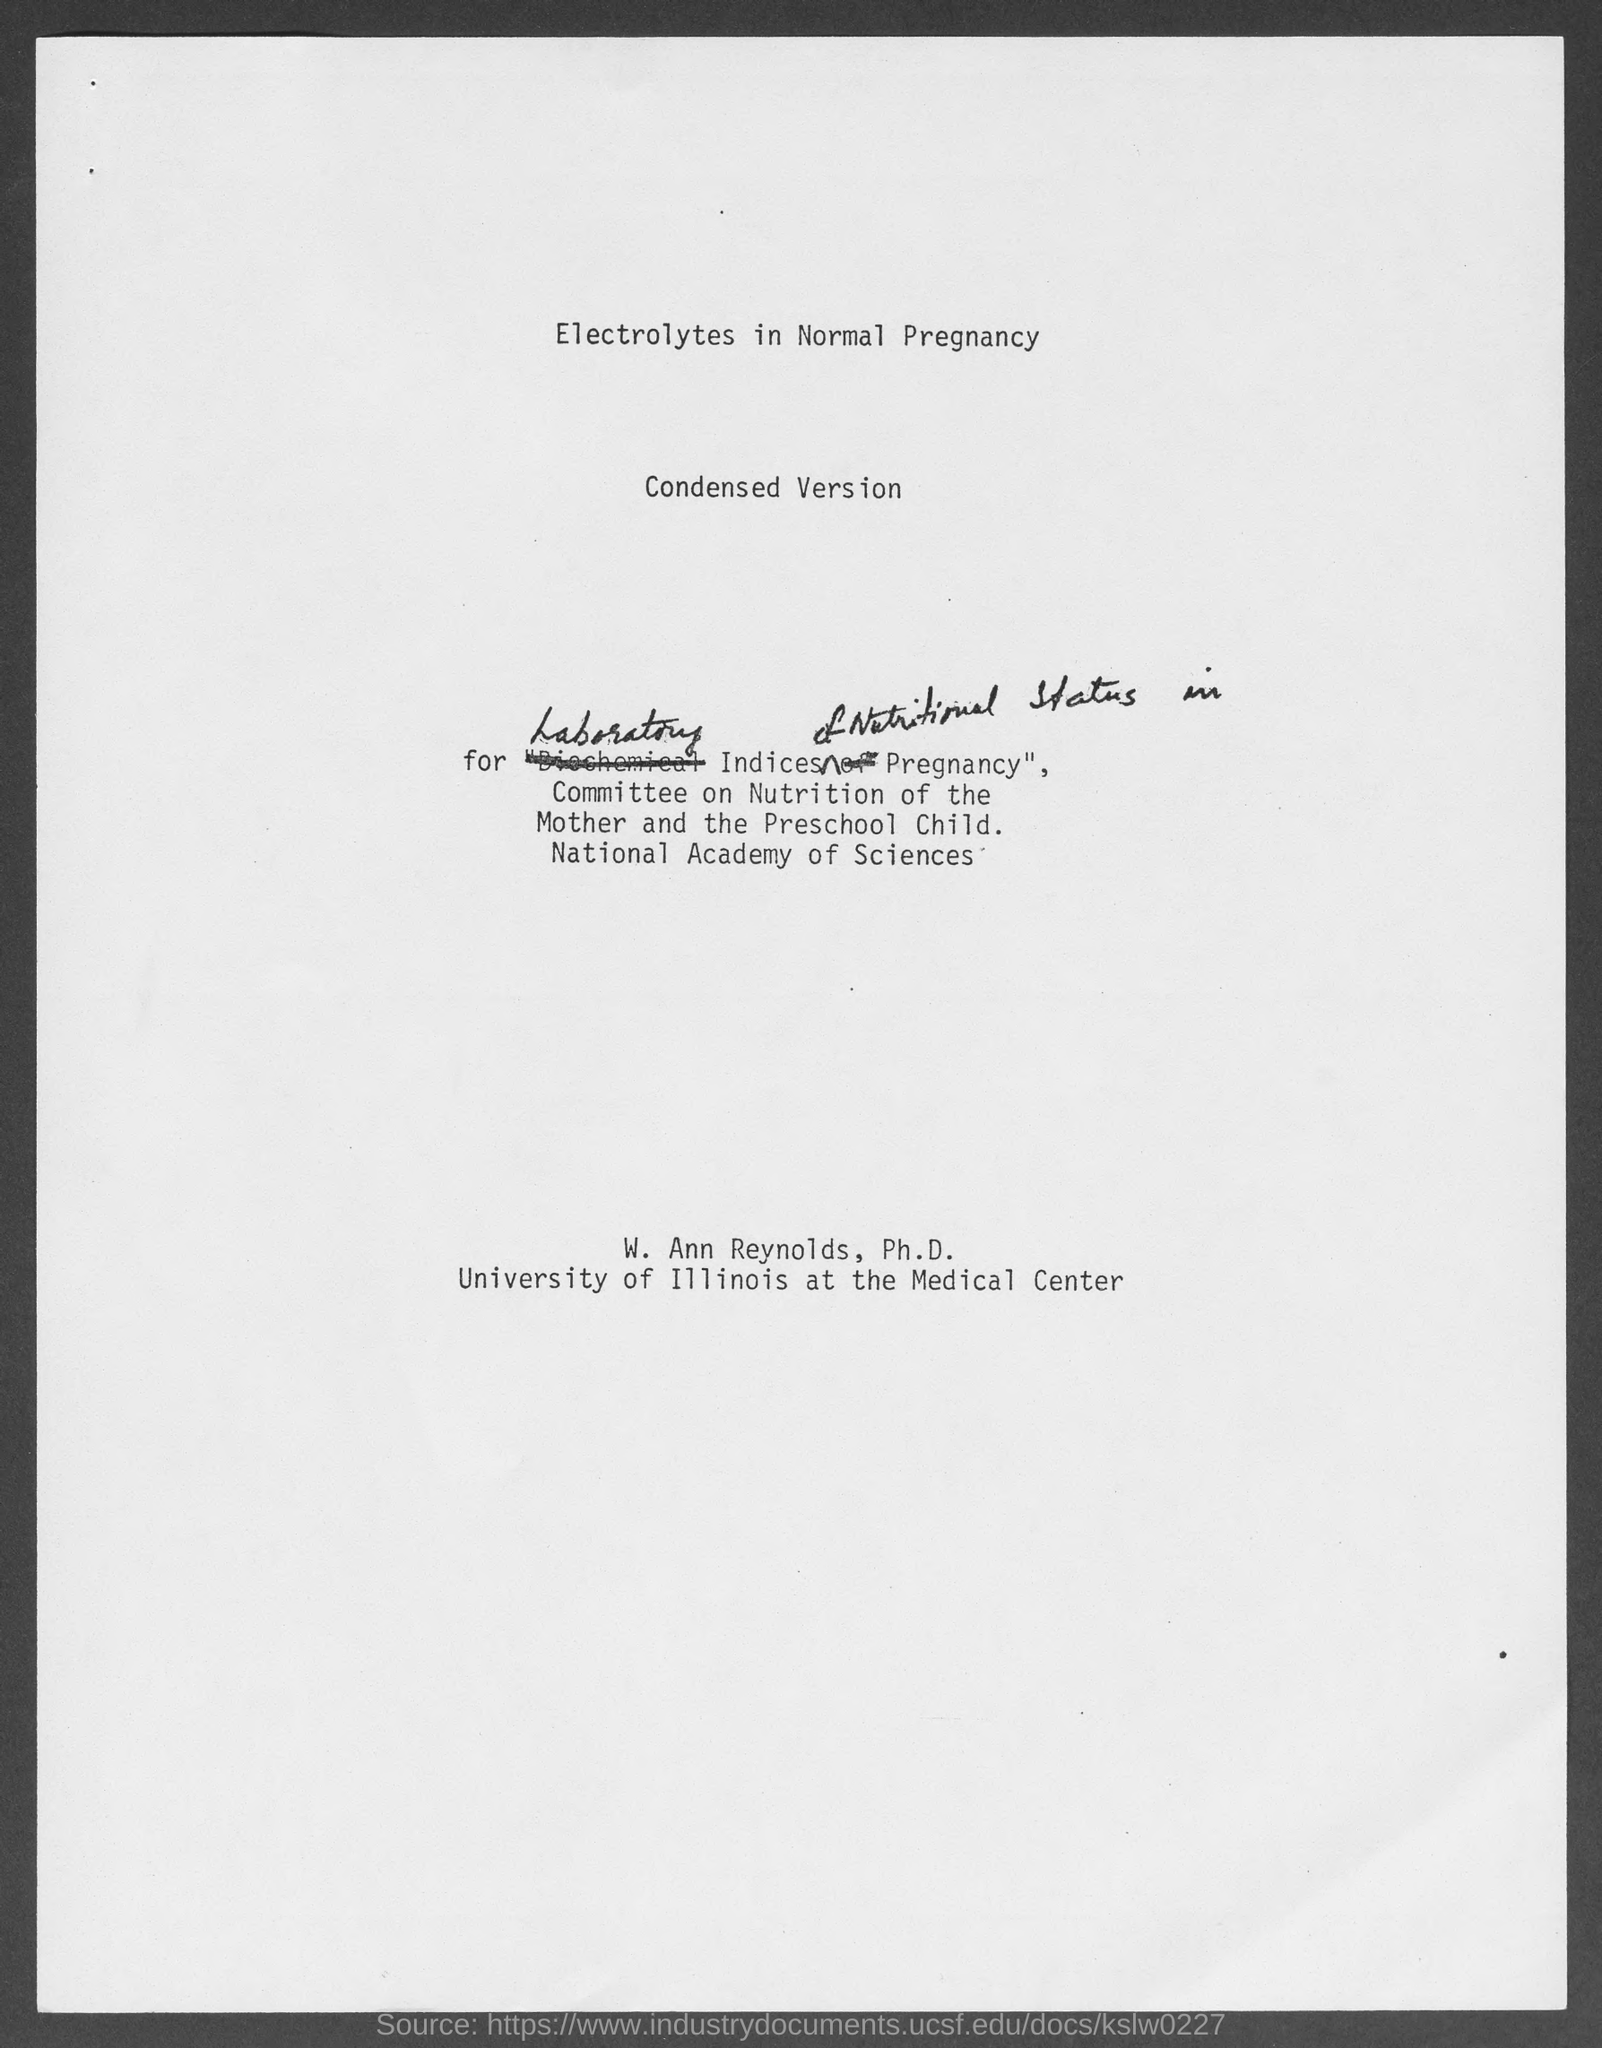Outline some significant characteristics in this image. The heading at the top of the page is "Electrolytes in Normal Pregnancy. 